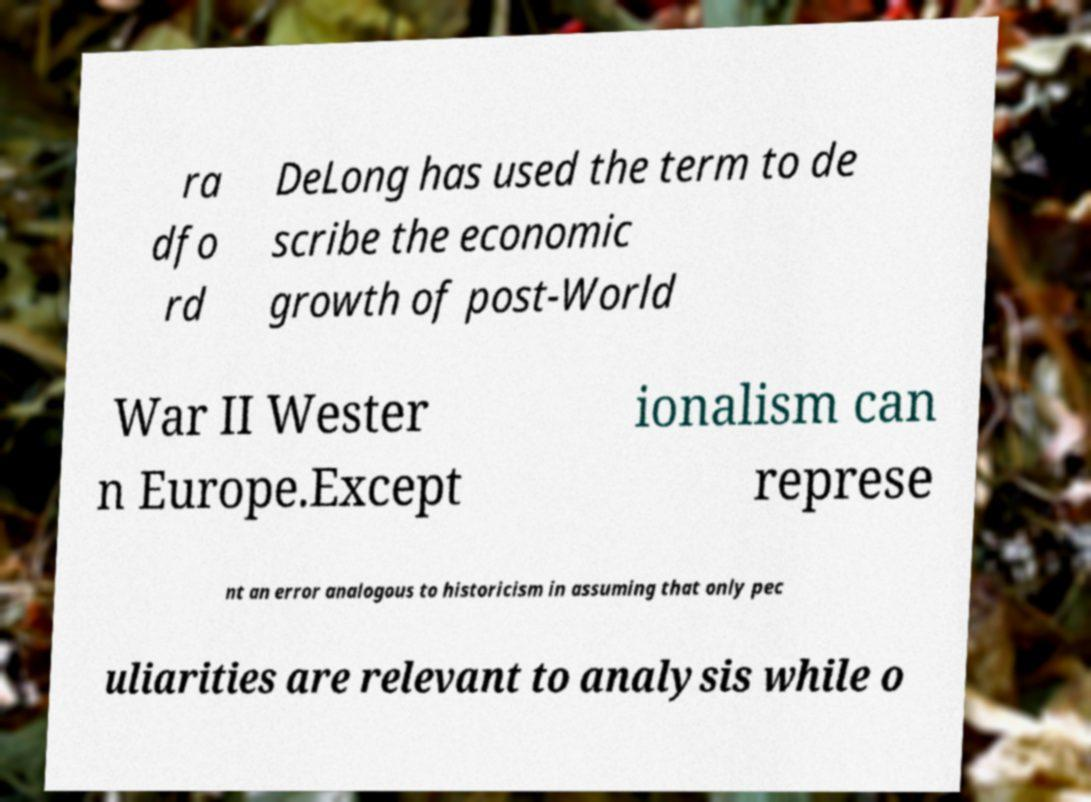For documentation purposes, I need the text within this image transcribed. Could you provide that? ra dfo rd DeLong has used the term to de scribe the economic growth of post-World War II Wester n Europe.Except ionalism can represe nt an error analogous to historicism in assuming that only pec uliarities are relevant to analysis while o 